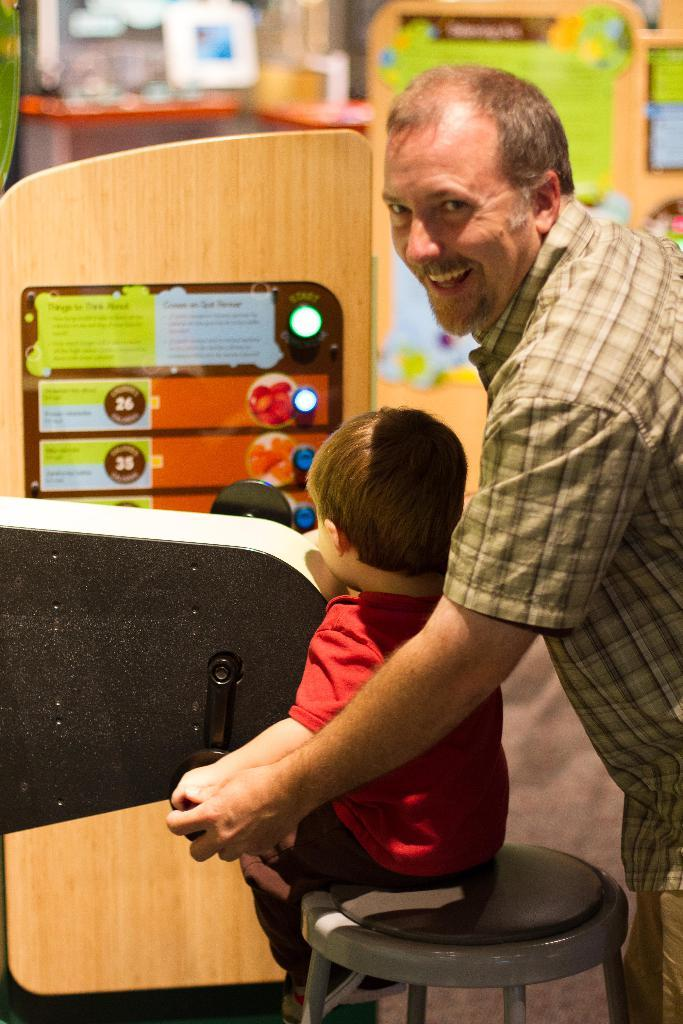What is the primary subject in the image? There is a person standing in the image. What is the child doing in the image? The child is sitting on a table in the image. Can you describe the background of the image? There are some objects in the background of the image. What type of wool is the person wearing in the image? There is no mention of wool or any specific clothing in the image, so it cannot be determined. 